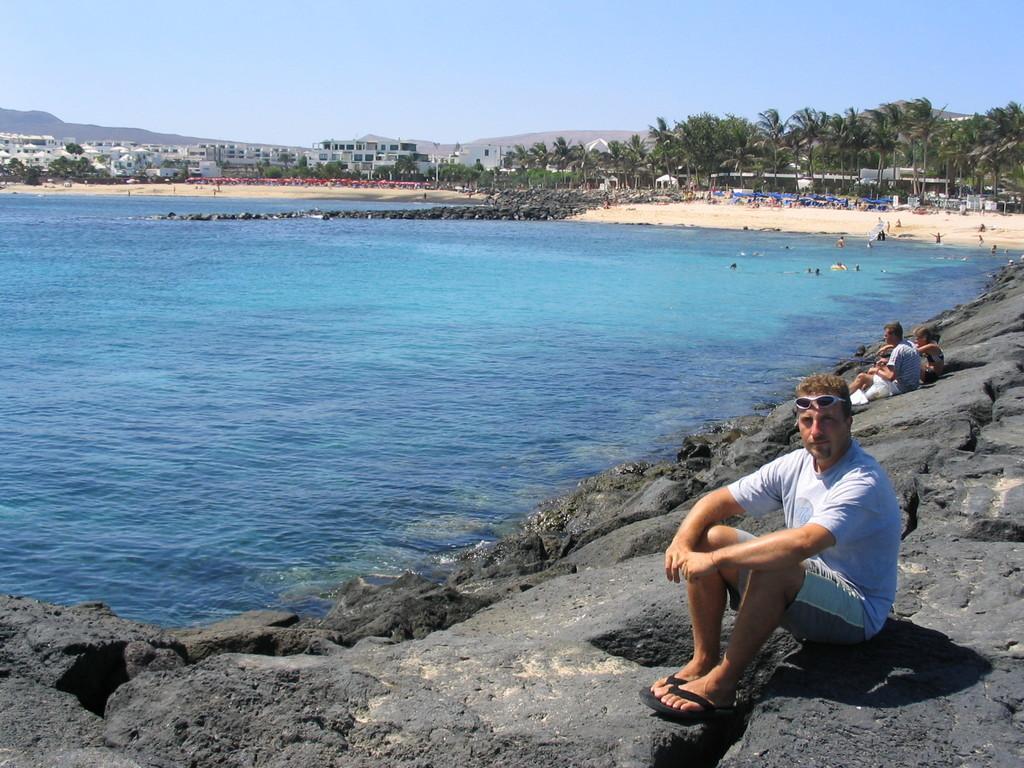Could you give a brief overview of what you see in this image? In this image we can see few people sitting on the rock, there are few trees, water, buildings and the sky in the background. 